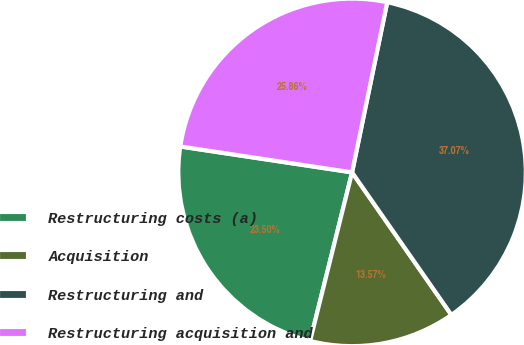Convert chart. <chart><loc_0><loc_0><loc_500><loc_500><pie_chart><fcel>Restructuring costs (a)<fcel>Acquisition<fcel>Restructuring and<fcel>Restructuring acquisition and<nl><fcel>23.5%<fcel>13.57%<fcel>37.07%<fcel>25.86%<nl></chart> 